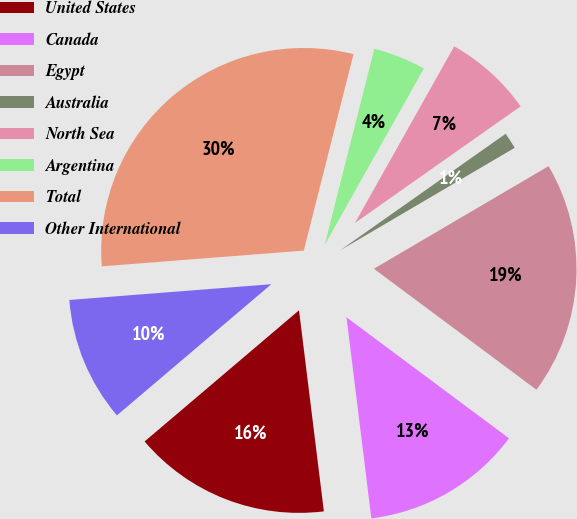<chart> <loc_0><loc_0><loc_500><loc_500><pie_chart><fcel>United States<fcel>Canada<fcel>Egypt<fcel>Australia<fcel>North Sea<fcel>Argentina<fcel>Total<fcel>Other International<nl><fcel>15.75%<fcel>12.86%<fcel>18.64%<fcel>1.31%<fcel>7.09%<fcel>4.2%<fcel>30.19%<fcel>9.97%<nl></chart> 